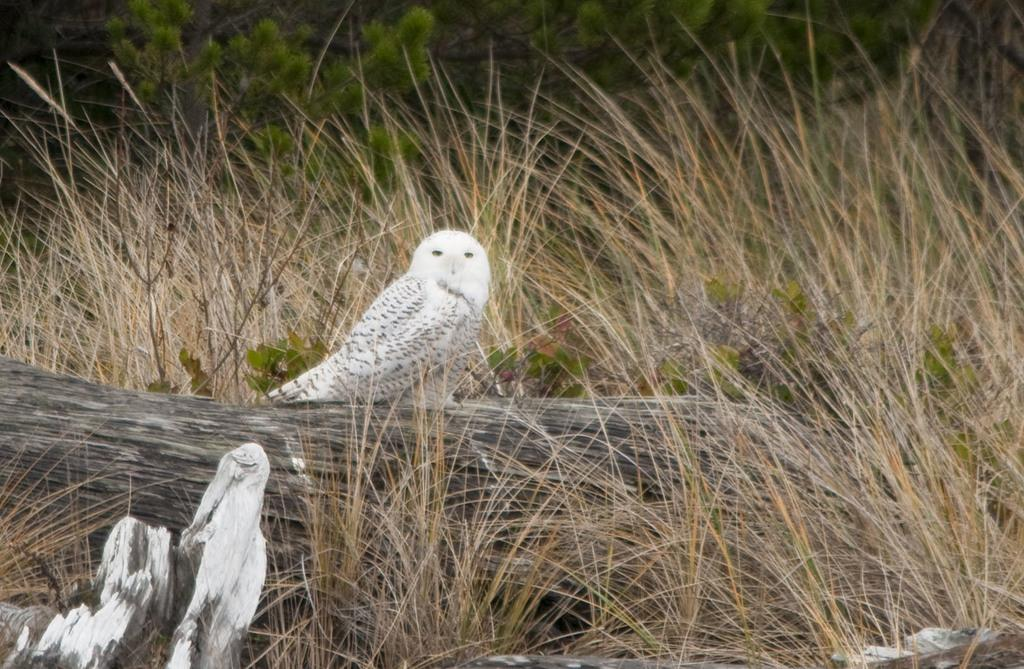What type of animal is in the image? There is a bird in the image. Where is the bird located? The bird is on a wooden log. What type of vegetation is visible in the image? There is grass visible in the image. What can be seen at the top of the image? There are plants at the top of the image. What type of wine is being served at the bird's party in the image? There is no wine or party present in the image; it features a bird on a wooden log with grass and plants in the background. 